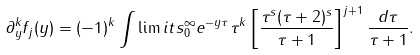Convert formula to latex. <formula><loc_0><loc_0><loc_500><loc_500>\partial _ { y } ^ { k } f _ { j } ( y ) = ( - 1 ) ^ { k } \int \lim i t s _ { 0 } ^ { \infty } e ^ { - y \tau } \tau ^ { k } \left [ \frac { \tau ^ { s } ( \tau + 2 ) ^ { s } } { \tau + 1 } \right ] ^ { j + 1 } \frac { d \tau } { \tau + 1 } .</formula> 